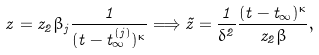<formula> <loc_0><loc_0><loc_500><loc_500>z = z _ { 2 } \beta _ { j } \frac { 1 } { ( t - t _ { \infty } ^ { ( j ) } ) ^ { \kappa } } \Longrightarrow \tilde { z } = \frac { 1 } { \delta ^ { 2 } } \frac { ( t - t _ { \infty } ) ^ { \kappa } } { z _ { 2 } \beta } ,</formula> 